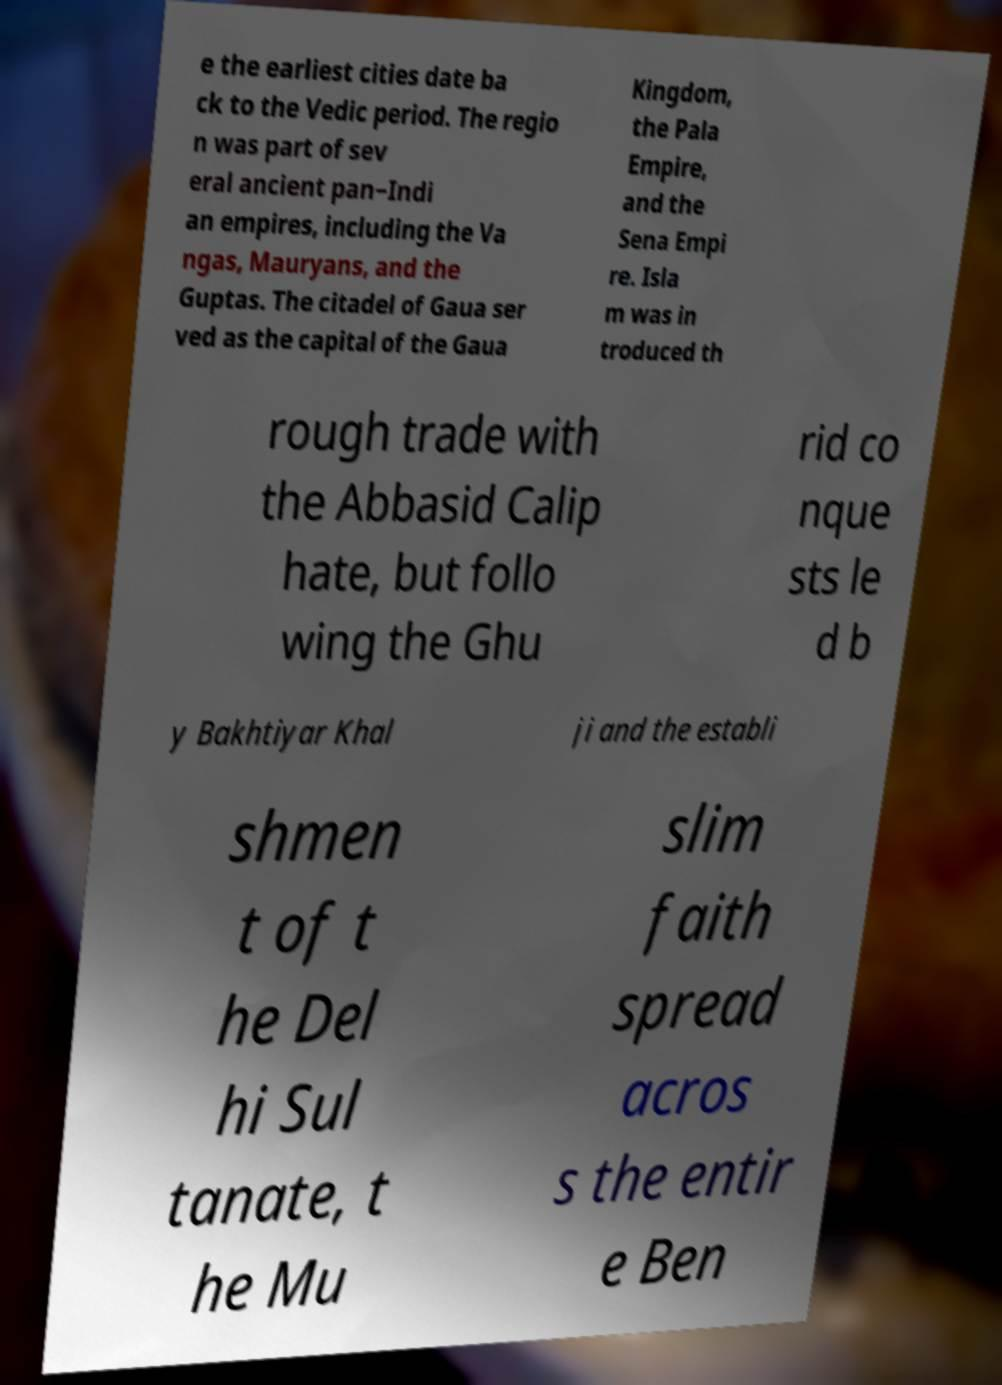What messages or text are displayed in this image? I need them in a readable, typed format. e the earliest cities date ba ck to the Vedic period. The regio n was part of sev eral ancient pan−Indi an empires, including the Va ngas, Mauryans, and the Guptas. The citadel of Gaua ser ved as the capital of the Gaua Kingdom, the Pala Empire, and the Sena Empi re. Isla m was in troduced th rough trade with the Abbasid Calip hate, but follo wing the Ghu rid co nque sts le d b y Bakhtiyar Khal ji and the establi shmen t of t he Del hi Sul tanate, t he Mu slim faith spread acros s the entir e Ben 